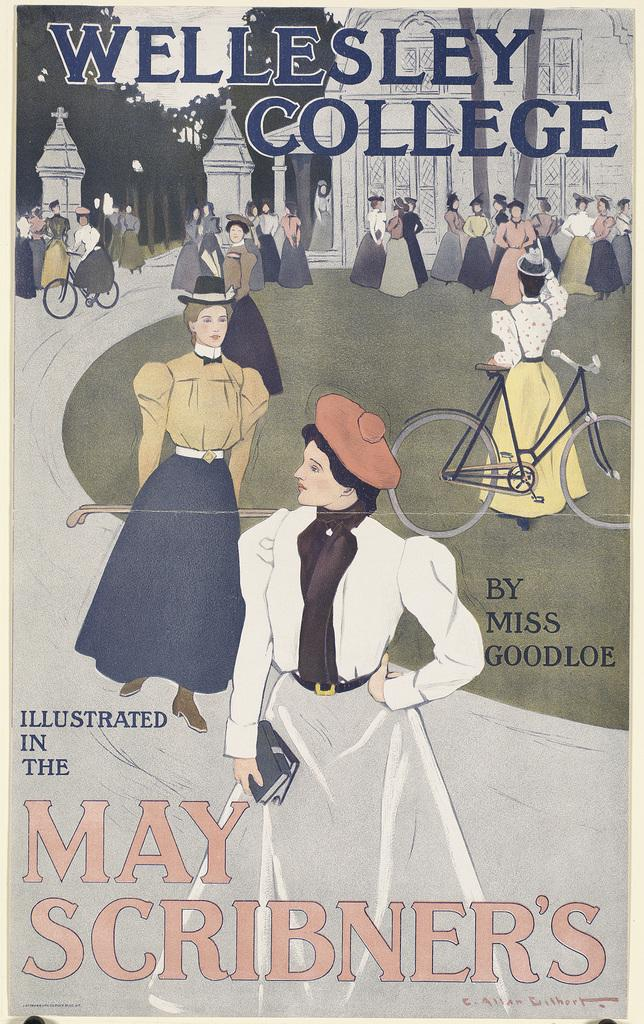What type of publication does the image represent? The image is a front cover of a book. What can be seen in the foreground of the image? There is a crowd in the image. What else is present on the ground in the image? There are vehicles on the ground in the image. What is visible in the background of the image? There is a building, trees, and the sky visible in the background of the image. What type of fork is being used by the crowd in the image? There is no fork present in the image; it features a crowd, vehicles, a building, trees, and the sky. 